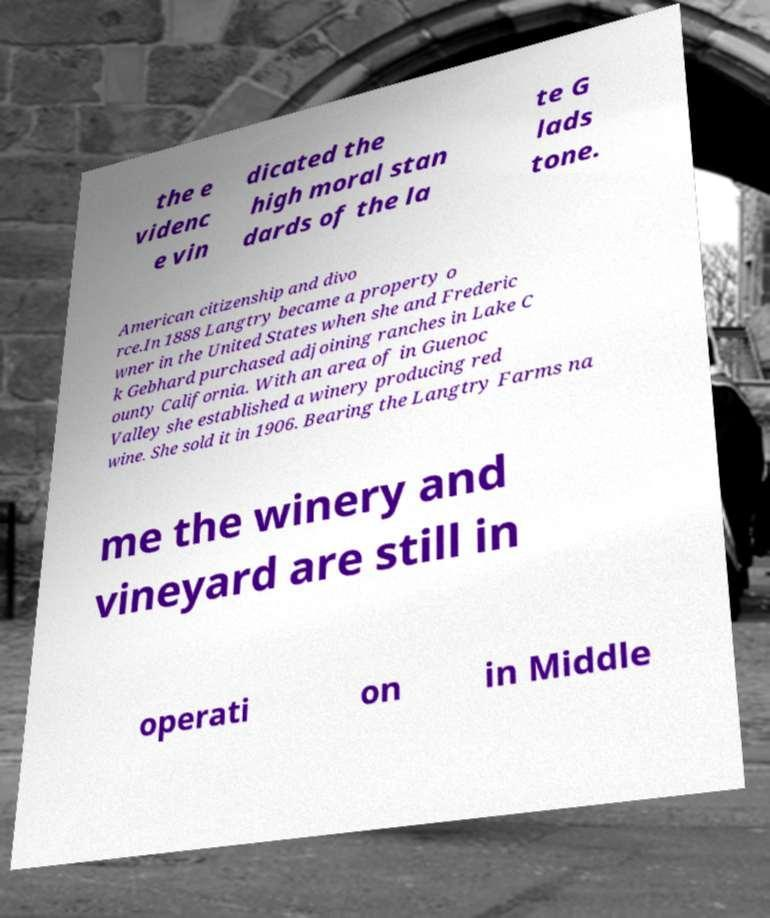I need the written content from this picture converted into text. Can you do that? the e videnc e vin dicated the high moral stan dards of the la te G lads tone. American citizenship and divo rce.In 1888 Langtry became a property o wner in the United States when she and Frederic k Gebhard purchased adjoining ranches in Lake C ounty California. With an area of in Guenoc Valley she established a winery producing red wine. She sold it in 1906. Bearing the Langtry Farms na me the winery and vineyard are still in operati on in Middle 